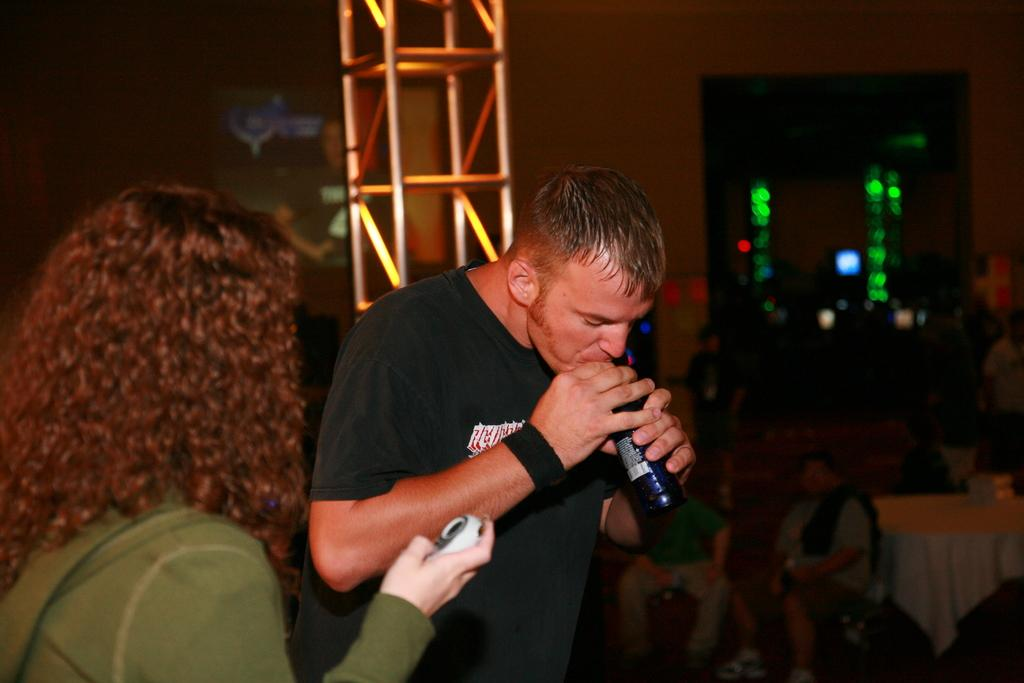How many people are present in the image? There are two people, a man and a woman, present in the image. What is the woman holding in the image? The woman is holding an object. What is the man holding in the image? The man is holding a bottle. What can be seen in the background of the image? There are people, a wall, a table, and objects in the background of the image. What type of camera can be seen in the image? There is no camera present in the image. How does the woman maintain her balance while holding the object in the image? The image does not provide information about the woman's balance or the nature of the object she is holding, so it cannot be determined from the image. 